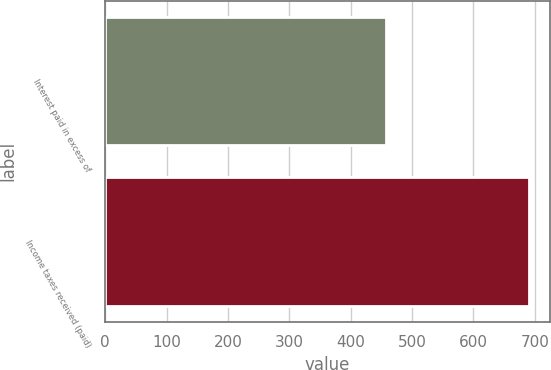Convert chart. <chart><loc_0><loc_0><loc_500><loc_500><bar_chart><fcel>Interest paid in excess of<fcel>Income taxes received (paid)<nl><fcel>457<fcel>690<nl></chart> 